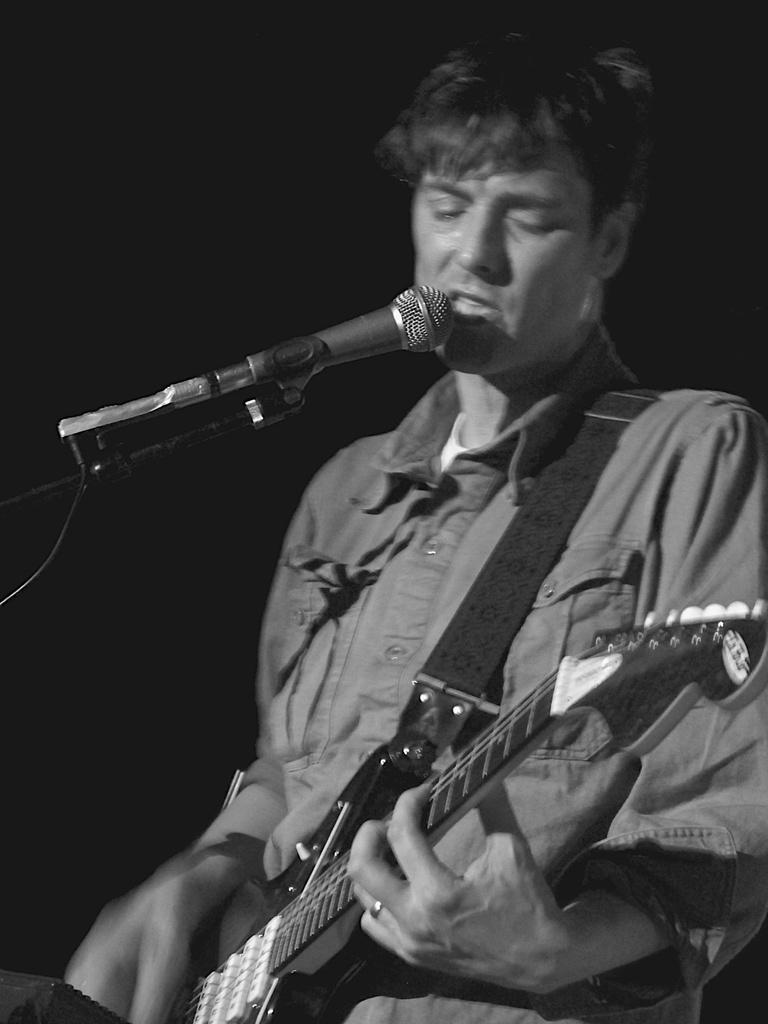Can you describe this image briefly? In the middle of the image a man is standing and playing guitar and there is a microphone. 